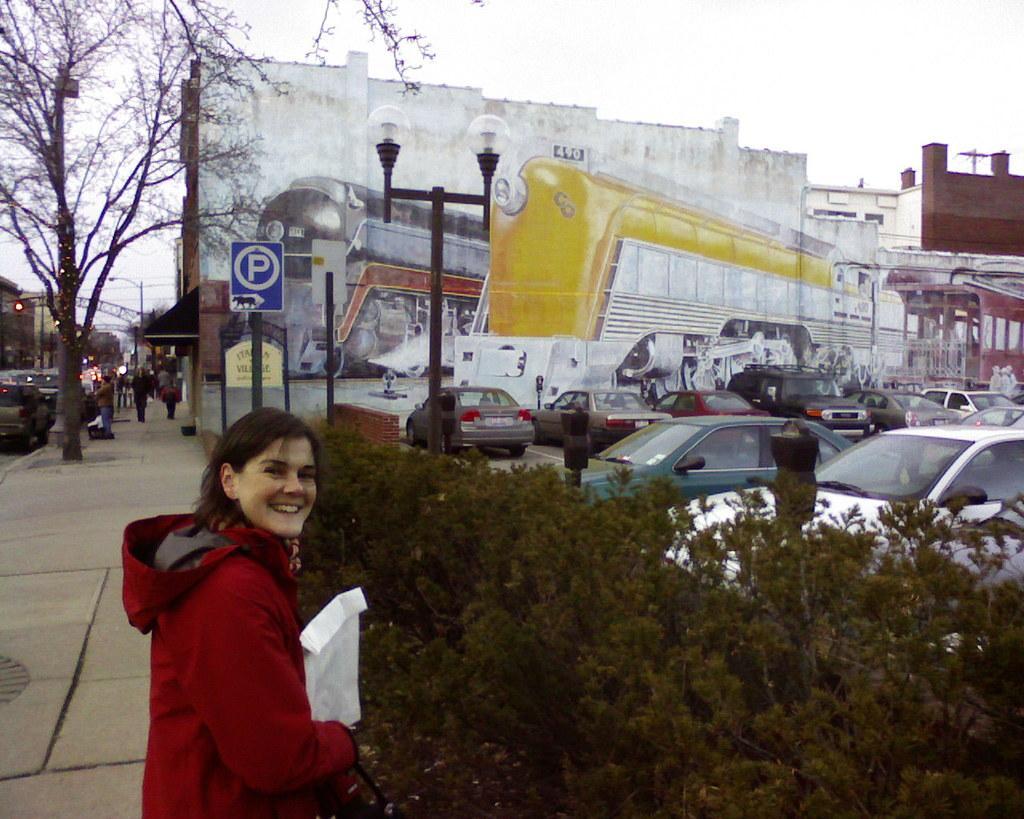How would you summarize this image in a sentence or two? There is a parking area and there are many vehicles parked inside the parking area,outside that there is a street light and a parking board and beside that there is a footpath. On the footpath there are some people walking and in the front there is a woman standing in front of the plants and she is wearing red sweater and she is also smiling. In the background there are some other vehicles moving on the road and beside the road there is a big building. In the background there is a sky. 